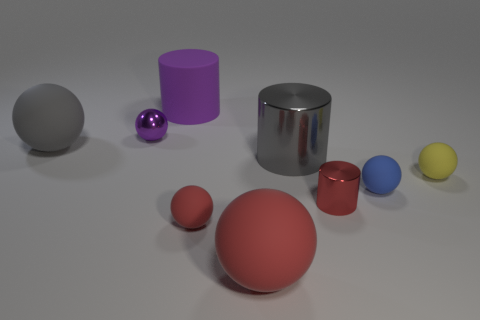What size is the metallic object that is the same color as the matte cylinder?
Ensure brevity in your answer.  Small. How many rubber cylinders have the same color as the metallic ball?
Provide a short and direct response. 1. What material is the gray object on the right side of the gray object left of the small purple object made of?
Your answer should be compact. Metal. There is a cylinder in front of the gray thing that is to the right of the large ball that is on the left side of the small red ball; what is its size?
Your answer should be very brief. Small. Is the shape of the yellow thing the same as the object left of the small purple ball?
Provide a short and direct response. Yes. What is the small red sphere made of?
Your answer should be compact. Rubber. How many matte things are either purple spheres or purple things?
Offer a very short reply. 1. Is the number of big metal cylinders left of the big red rubber object less than the number of tiny yellow matte objects that are behind the purple rubber object?
Make the answer very short. No. Are there any tiny things that are left of the large gray metal cylinder to the right of the large sphere that is behind the big gray cylinder?
Offer a very short reply. Yes. What material is the large object that is the same color as the large metallic cylinder?
Provide a succinct answer. Rubber. 